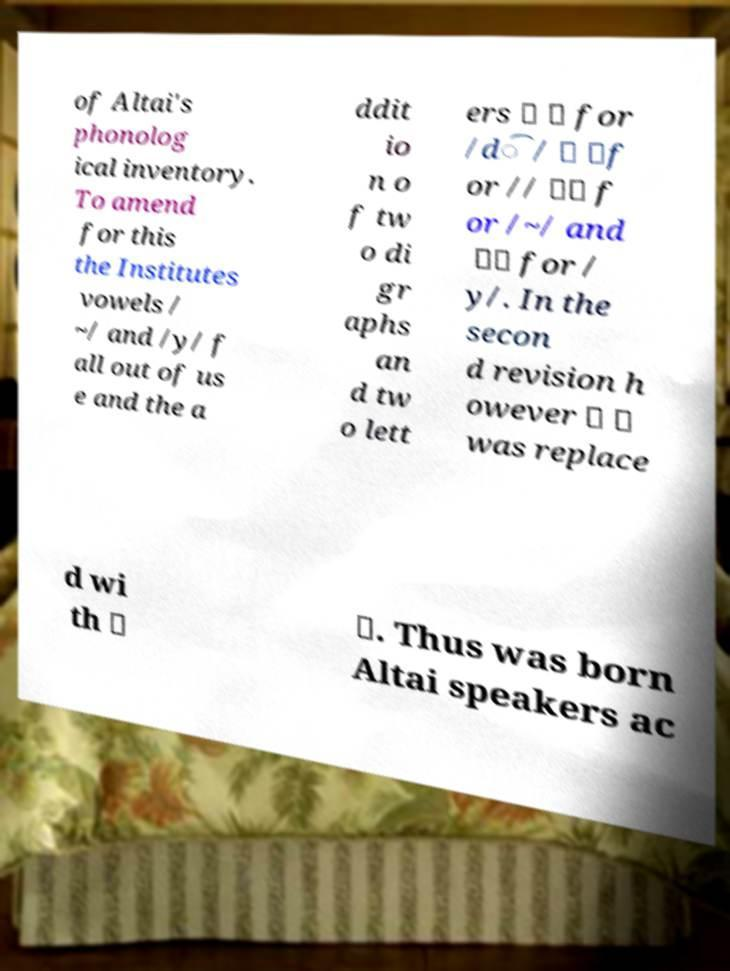What messages or text are displayed in this image? I need them in a readable, typed format. of Altai's phonolog ical inventory. To amend for this the Institutes vowels / ~/ and /y/ f all out of us e and the a ddit io n o f tw o di gr aphs an d tw o lett ers 〈 〉 for /d͡/ 〈 〉f or // 〈〉 f or /~/ and 〈〉 for / y/. In the secon d revision h owever 〈 〉 was replace d wi th 〈 〉. Thus was born Altai speakers ac 